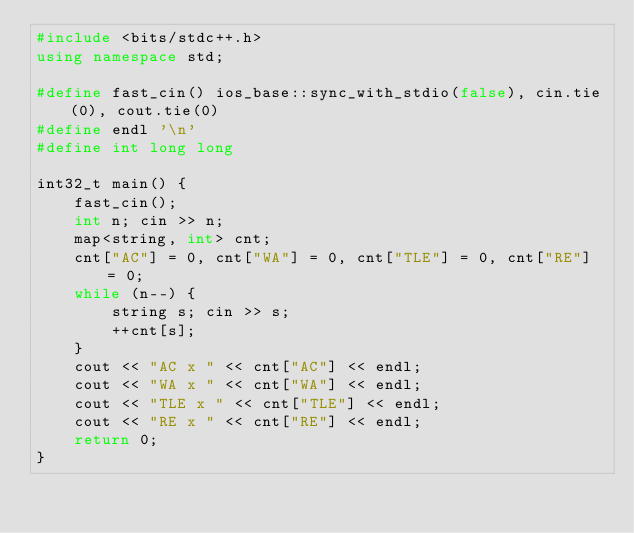<code> <loc_0><loc_0><loc_500><loc_500><_C++_>#include <bits/stdc++.h>
using namespace std;
						
#define fast_cin() ios_base::sync_with_stdio(false), cin.tie(0), cout.tie(0)
#define endl '\n'
#define int long long
				
int32_t main() {
	fast_cin();  
	int n; cin >> n;
	map<string, int> cnt;
	cnt["AC"] = 0, cnt["WA"] = 0, cnt["TLE"] = 0, cnt["RE"] = 0;
	while (n--) {
		string s; cin >> s;
		++cnt[s];
	}
	cout << "AC x " << cnt["AC"] << endl;
	cout << "WA x " << cnt["WA"] << endl;
	cout << "TLE x " << cnt["TLE"] << endl;
	cout << "RE x " << cnt["RE"] << endl;
	return 0;
}</code> 